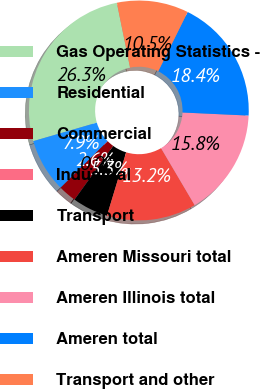<chart> <loc_0><loc_0><loc_500><loc_500><pie_chart><fcel>Gas Operating Statistics -<fcel>Residential<fcel>Commercial<fcel>Industrial<fcel>Transport<fcel>Ameren Missouri total<fcel>Ameren Illinois total<fcel>Ameren total<fcel>Transport and other<nl><fcel>26.3%<fcel>7.9%<fcel>2.64%<fcel>0.01%<fcel>5.27%<fcel>13.16%<fcel>15.78%<fcel>18.41%<fcel>10.53%<nl></chart> 